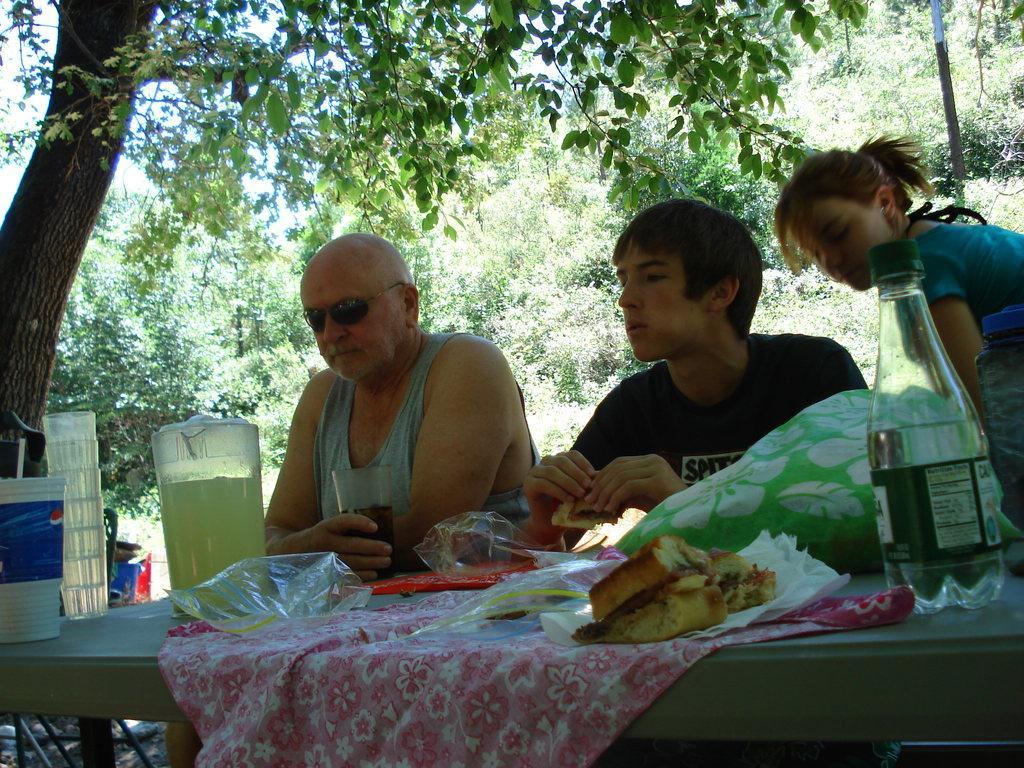How would you summarize this image in a sentence or two? in this image i can see a table and a cloth over it. there are burgers on it and a water bottle. there are three people in this image sitting. the person at the left is holding a glass. behind him there are many trees. 